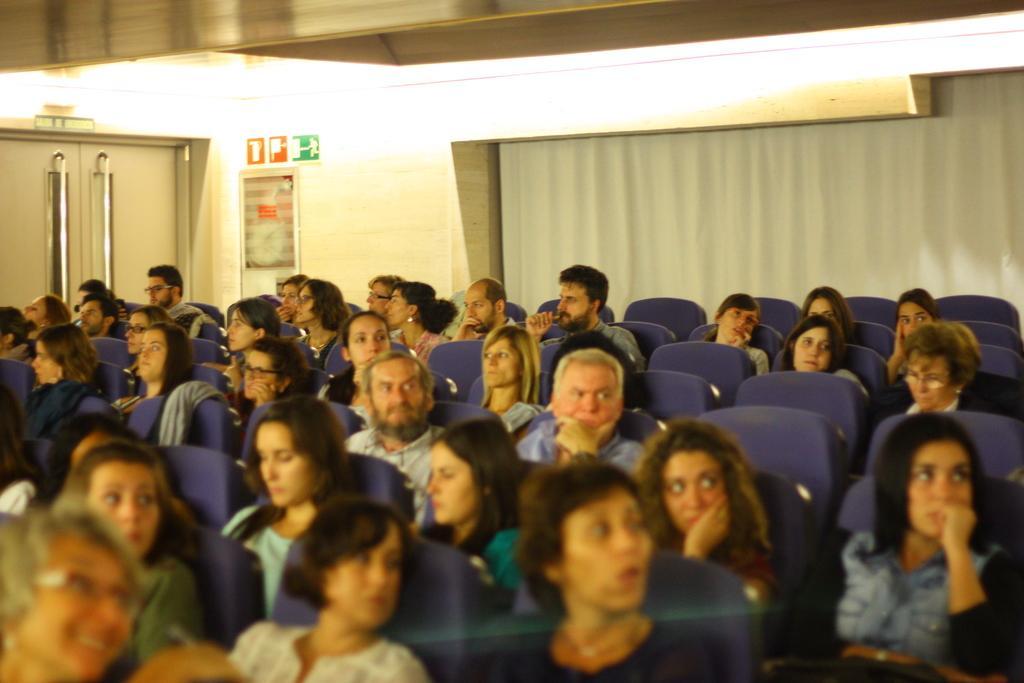Could you give a brief overview of what you see in this image? In this image there are few people sitting on the chairs. At the top there is ceiling with the lights. On the left side top there is a door. On the right side there is a curtain in the background. In the middle we can see there are symbol boards attached to the wall. 